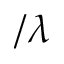Convert formula to latex. <formula><loc_0><loc_0><loc_500><loc_500>/ \lambda</formula> 